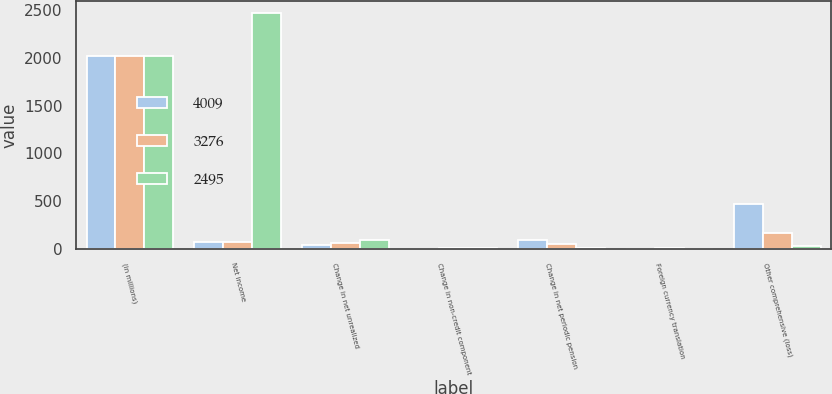Convert chart. <chart><loc_0><loc_0><loc_500><loc_500><stacked_bar_chart><ecel><fcel>(in millions)<fcel>Net income<fcel>Change in net unrealized<fcel>Change in non-credit component<fcel>Change in net periodic pension<fcel>Foreign currency translation<fcel>Other comprehensive (loss)<nl><fcel>4009<fcel>2018<fcel>76<fcel>37<fcel>2<fcel>90<fcel>1<fcel>474<nl><fcel>3276<fcel>2017<fcel>76<fcel>65<fcel>4<fcel>51<fcel>3<fcel>166<nl><fcel>2495<fcel>2016<fcel>2470<fcel>87<fcel>5<fcel>13<fcel>2<fcel>25<nl></chart> 